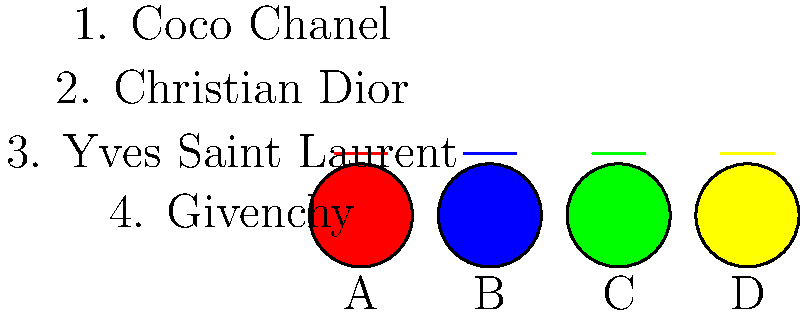Chérie, at the last Cannes Film Festival, four stunning socialites wore these exquisite designer gowns. Can you match each dress color to the correct haute couture designer? Which dress do you think belonged to the scandalous starlet who caused quite a stir that evening? Let's unravel this fashion mystery step by step, ma chère:

1. The red dress (A) is likely a Valentino creation. Valentino is famous for its "Valentino Red," but it's not one of our options.

2. The blue dress (B) screams Christian Dior. Dior often uses deep, rich blues in their designs, especially for elegant evening gowns.

3. The green dress (C) is probably by Yves Saint Laurent. YSL is known for bold, vibrant colors, and this emerald green fits their aesthetic perfectly.

4. The yellow dress (D) could be a Givenchy piece. Givenchy often incorporates sunny, optimistic colors in their collections.

5. Coco Chanel, while iconic, was known more for her little black dresses and tweed suits, so she doesn't quite fit with these bold, colorful gowns.

As for the scandalous starlet, darling, it's hard to say without more gossip! But if I had to guess, I'd say the red dress (A) caused the most buzz. Red is always eye-catching and often associated with passion and scandal!
Answer: B-2 (Dior), C-3 (YSL), D-4 (Givenchy); Red dress (A) likely caused a stir 